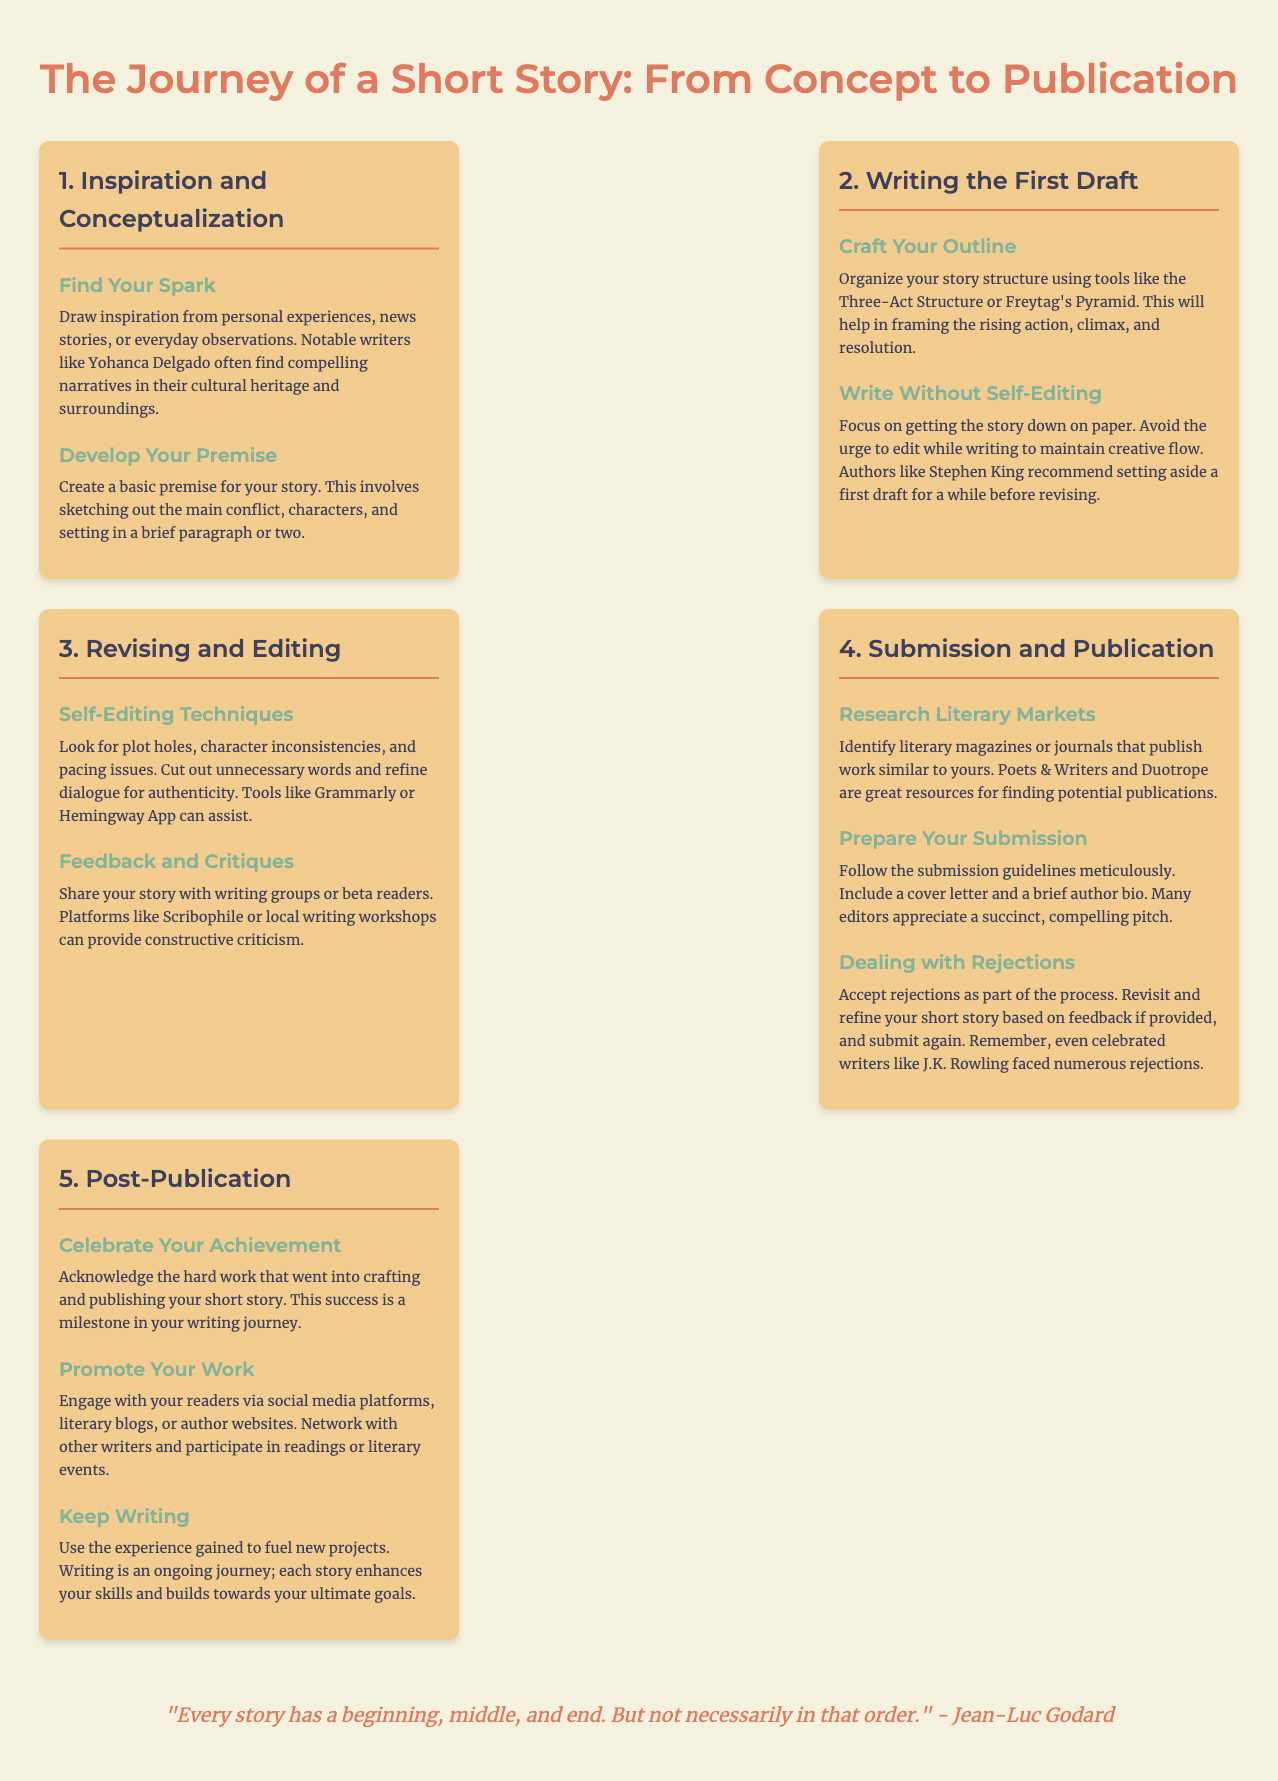What are common sources of inspiration? The document mentions drawing inspiration from personal experiences, news stories, or everyday observations.
Answer: Personal experiences, news stories, observations What is the first step in the writing process? The first step involves inspiration and conceptualization, specifically finding your spark.
Answer: Inspiration and conceptualization What publication tools are suggested for self-editing? The document recommends using tools like Grammarly or Hemingway App for self-editing techniques.
Answer: Grammarly, Hemingway App What is one method for structuring a story? The Three-Act Structure or Freytag's Pyramid are mentioned as methods for organizing story structure.
Answer: Three-Act Structure, Freytag's Pyramid How should writers handle rejections? Writers are advised to accept rejections as part of the process and revisit their stories based on feedback.
Answer: Accept as part of the process What should be included in a submission? A cover letter and a brief author bio should be included as part of the submission.
Answer: Cover letter and brief author bio What is an important aspect of promotion post-publication? Engaging with readers via social media platforms is highlighted as an important aspect of promotion.
Answer: Social media platforms What does the quote at the end emphasize? The quote emphasizes that every story has a structure, but the order can vary, indicating flexibility in storytelling.
Answer: Flexibility in storytelling 